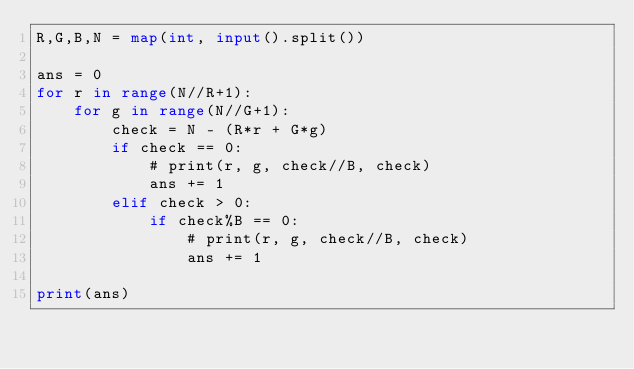<code> <loc_0><loc_0><loc_500><loc_500><_Python_>R,G,B,N = map(int, input().split())

ans = 0
for r in range(N//R+1):
    for g in range(N//G+1):
        check = N - (R*r + G*g)
        if check == 0:
            # print(r, g, check//B, check)
            ans += 1
        elif check > 0:
            if check%B == 0:
                # print(r, g, check//B, check)
                ans += 1

print(ans)</code> 